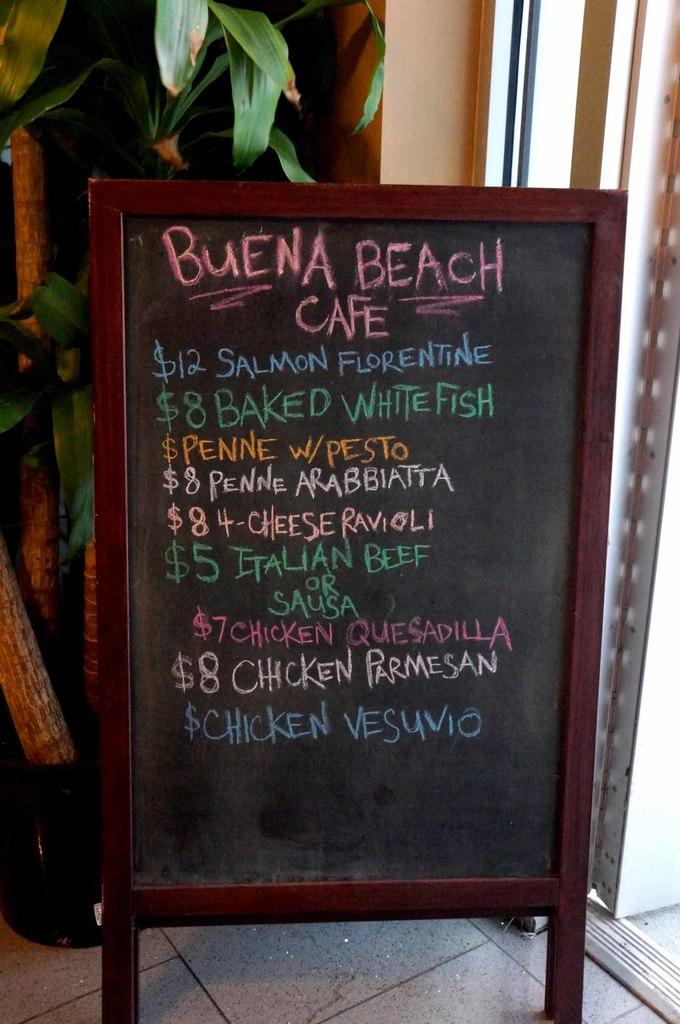What is the main object in the middle of the image? There is a price board in the middle of the image. What can be seen behind the price board? There is a plant and a wall in the background of the image. What does your dad think about the price board in the image? The image does not provide any information about your dad's opinion on the price board, as it only shows the price board and related elements. 